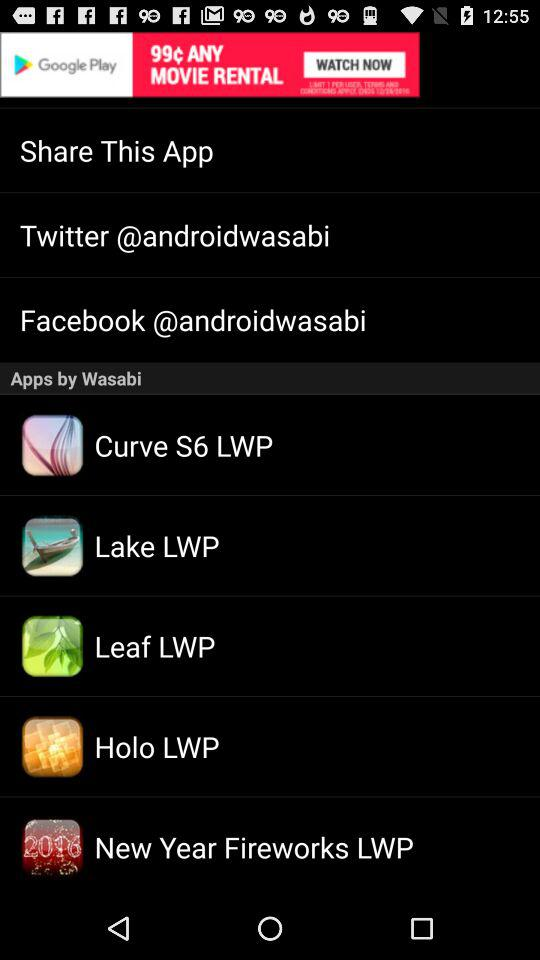What is the Facebook user name? The Facebook user name is "@androidwasabi". 